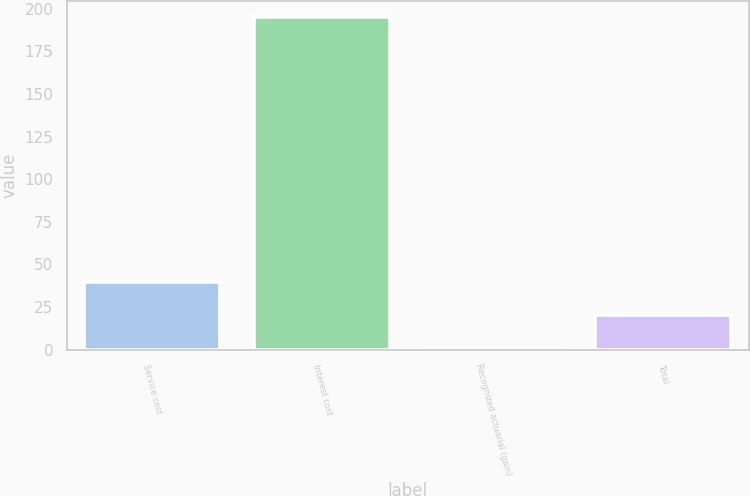Convert chart to OTSL. <chart><loc_0><loc_0><loc_500><loc_500><bar_chart><fcel>Service cost<fcel>Interest cost<fcel>Recognized actuarial (gain)<fcel>Total<nl><fcel>39.8<fcel>195<fcel>1<fcel>20.4<nl></chart> 